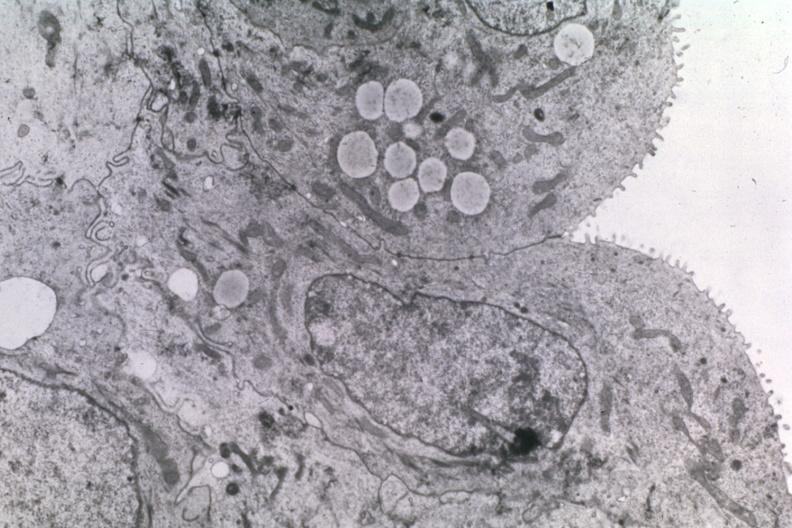what does this image show?
Answer the question using a single word or phrase. Dr garcia tumors 20 